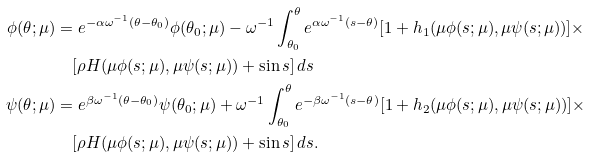<formula> <loc_0><loc_0><loc_500><loc_500>\phi ( \theta ; \mu ) & = e ^ { - \alpha \omega ^ { - 1 } ( \theta - \theta _ { 0 } ) } \phi ( \theta _ { 0 } ; \mu ) - \omega ^ { - 1 } \int _ { \theta _ { 0 } } ^ { \theta } e ^ { \alpha \omega ^ { - 1 } ( s - \theta ) } [ 1 + h _ { 1 } ( \mu \phi ( s ; \mu ) , \mu \psi ( s ; \mu ) ) ] \times \\ & \quad [ \rho H ( \mu \phi ( s ; \mu ) , \mu \psi ( s ; \mu ) ) + \sin s ] \, d s \\ \psi ( \theta ; \mu ) & = e ^ { \beta \omega ^ { - 1 } ( \theta - \theta _ { 0 } ) } \psi ( \theta _ { 0 } ; \mu ) + \omega ^ { - 1 } \int _ { \theta _ { 0 } } ^ { \theta } e ^ { - \beta \omega ^ { - 1 } ( s - \theta ) } [ 1 + h _ { 2 } ( \mu \phi ( s ; \mu ) , \mu \psi ( s ; \mu ) ) ] \times \\ & \quad [ \rho H ( \mu \phi ( s ; \mu ) , \mu \psi ( s ; \mu ) ) + \sin s ] \, d s .</formula> 